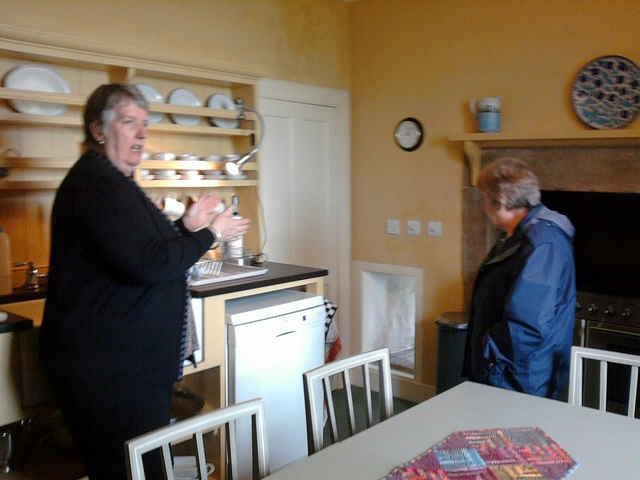Describe the objects in this image and their specific colors. I can see people in olive, black, lightpink, darkgray, and gray tones, dining table in olive, darkgray, and gray tones, people in olive, black, blue, navy, and darkblue tones, refrigerator in olive, white, darkgray, and lightblue tones, and chair in olive, darkgray, black, and lightgray tones in this image. 